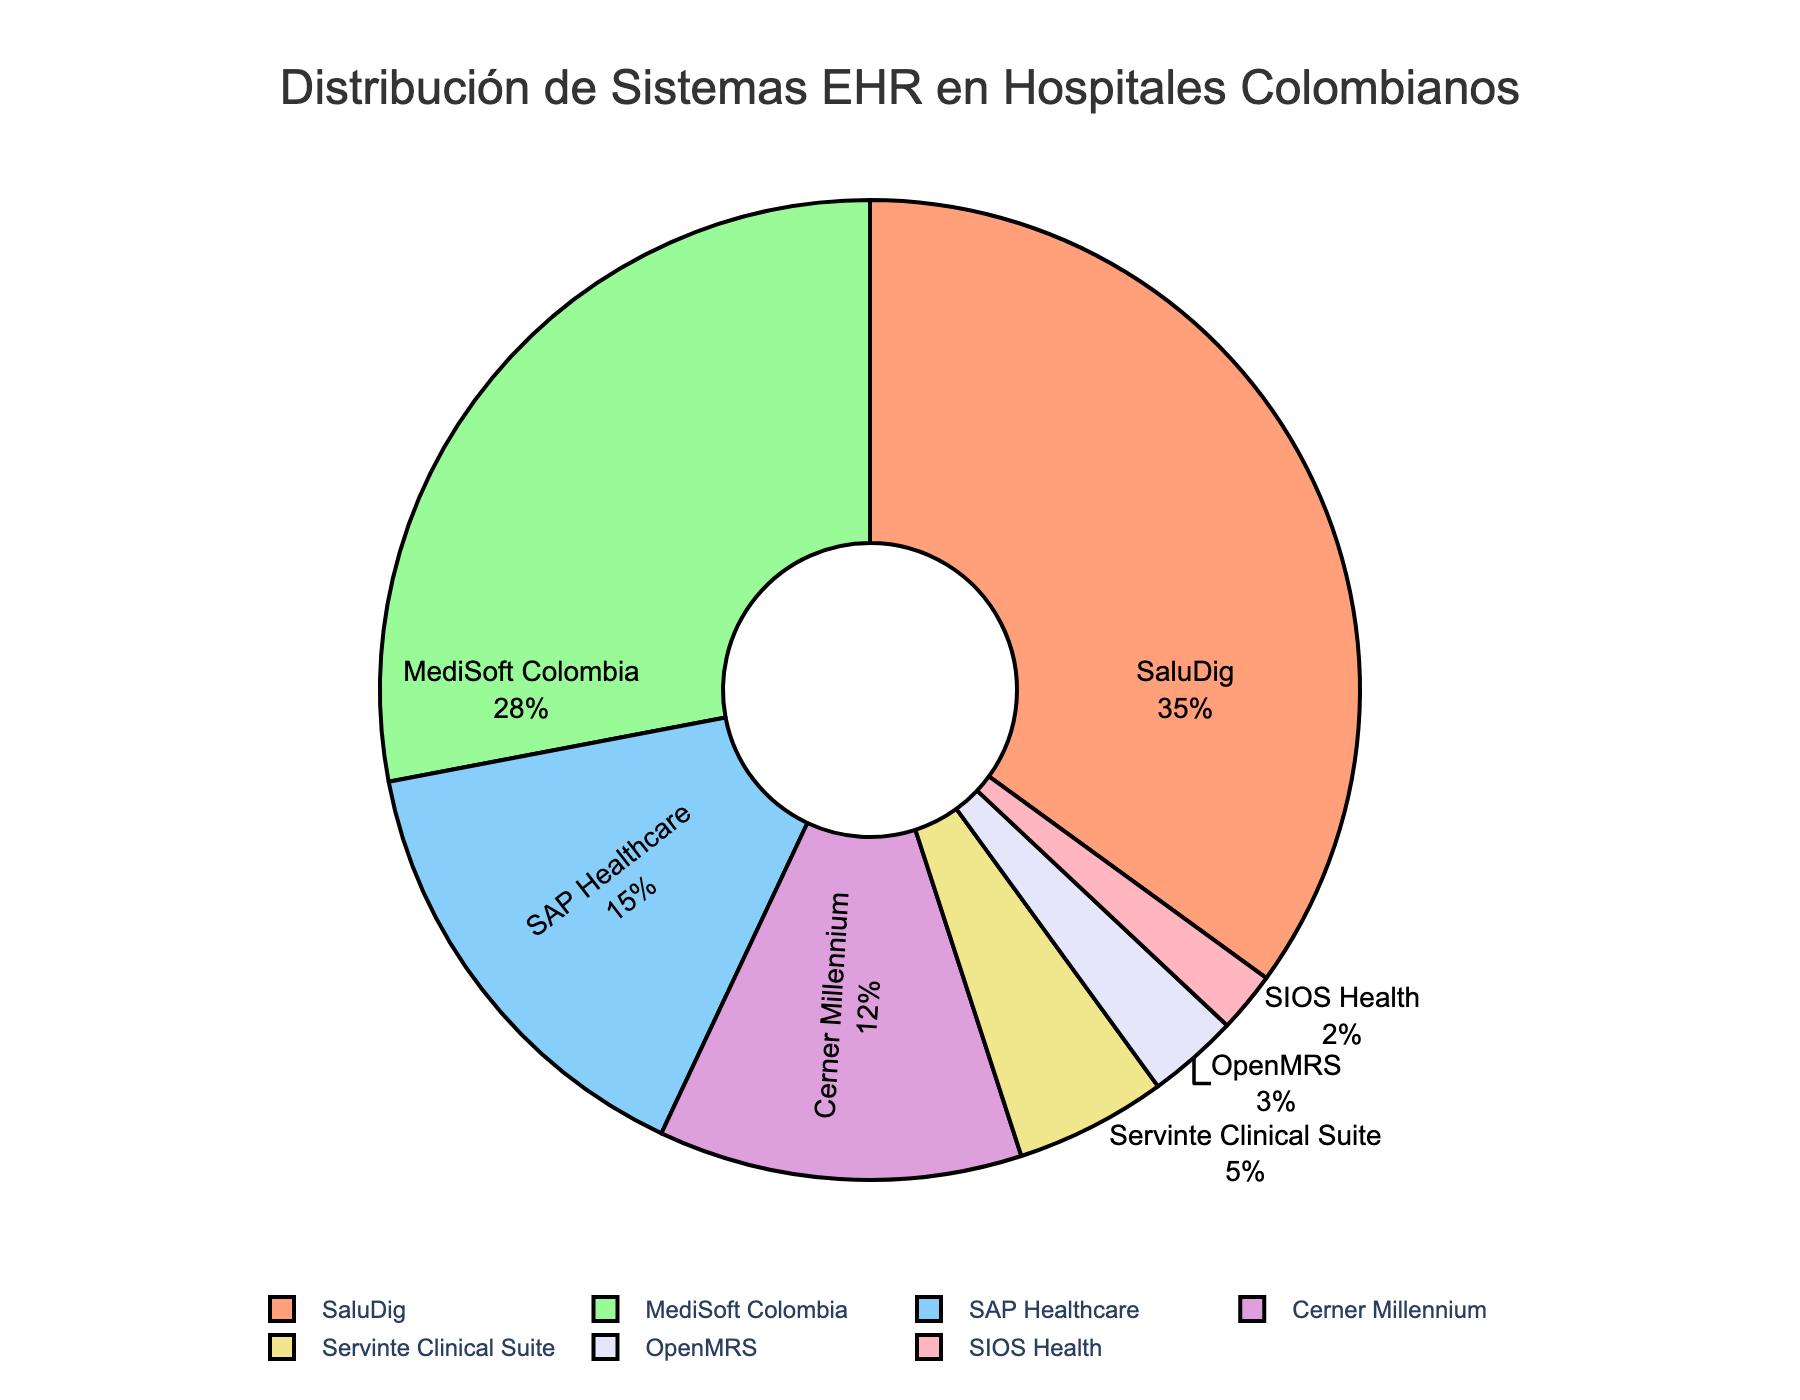What percentage of hospitals use SaluDig EHR system? SaluDig covers 35% of the pie chart, indicating the percentage of hospitals using this system.
Answer: 35% Which EHR system is used by the smallest percentage of hospitals? The smallest segment of the pie chart is labeled with SIOS Health, which shows 2%.
Answer: SIOS Health (2%) How does the percentage of hospitals using MediSoft Colombia compare to those using SAP Healthcare? MediSoft Colombia is at 28%, while SAP Healthcare is at 15%. 28% is greater than 15%, so more hospitals use MediSoft Colombia.
Answer: MediSoft Colombia has a higher percentage (28%) than SAP Healthcare (15%) What is the combined percentage of hospitals using Cerner Millennium and Servinte Clinical Suite? Cerner Millennium is 12% and Servinte Clinical Suite is 5%. Adding these together: 12 + 5 = 17.
Answer: 17% What is the visual color of the segment representing OpenMRS? The segment for OpenMRS is shaded in a light blue color.
Answer: Light blue Identify the system with the second-largest percentage and its visual color. MediSoft Colombia has the second-largest percentage (28%) and is represented in green.
Answer: MediSoft Colombia (28%), green Compare the combined percentage of hospitals using the top three EHR systems to those using the remaining systems. The top three are SaluDig (35%), MediSoft Colombia (28%), and SAP Healthcare (15%). Adding these: 35+28+15=78%. The remaining systems have: Cerner Millennium (12%), Servinte Clinical Suite (5%), OpenMRS (3%), and SIOS Health (2%), totaling: 12+5+3+2=22%. The top three combined percentage (78%) is greater than the remaining systems combined percentage (22%).
Answer: Top three: 78%, Remaining: 22% Which systems together make up less than 10% of the total? Servinte Clinical Suite (5%), OpenMRS (3%), and SIOS Health (2%) each cover less than 10%, and their combined percentage is 5+3+2=10%.
Answer: Servinte Clinical Suite, OpenMRS, SIOS Health What is the percentage difference between the highest and lowest used EHR systems? The highest is SaluDig (35%) and the lowest is SIOS Health (2%). The difference is 35 - 2 = 33%.
Answer: 33% If a hospital switches from using OpenMRS to MediSoft Colombia, how does this affect the percentage distribution for these systems? OpenMRS will lose 3% reducing it to 0%, and MediSoft Colombia will gain 3%, increasing it to 31%.
Answer: OpenMRS: 0%, MediSoft Colombia: 31% 